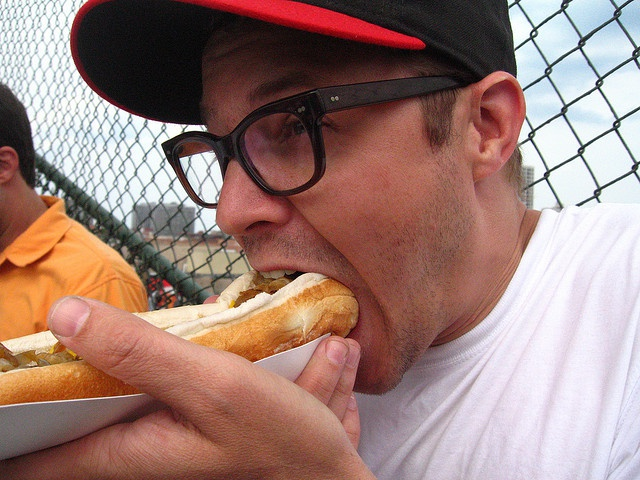Describe the objects in this image and their specific colors. I can see people in darkgray, brown, lavender, black, and maroon tones, hot dog in darkgray, orange, brown, beige, and tan tones, and people in darkgray, orange, black, and brown tones in this image. 